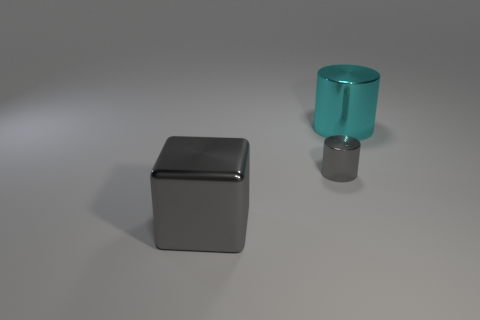Is the color of the cylinder behind the tiny metallic cylinder the same as the big thing that is to the left of the tiny shiny cylinder?
Offer a terse response. No. There is another thing that is the same size as the cyan metallic object; what is its color?
Give a very brief answer. Gray. Is the number of small metal cylinders that are left of the large cylinder the same as the number of tiny gray cylinders in front of the small cylinder?
Give a very brief answer. No. The gray object behind the thing that is in front of the small gray object is made of what material?
Your response must be concise. Metal. How many things are either large gray cubes or cyan matte spheres?
Your response must be concise. 1. There is a metallic object that is the same color as the big shiny block; what size is it?
Offer a very short reply. Small. Are there fewer shiny cubes than things?
Ensure brevity in your answer.  Yes. What size is the other cylinder that is made of the same material as the gray cylinder?
Give a very brief answer. Large. How big is the cyan object?
Provide a short and direct response. Large. What shape is the small thing?
Provide a succinct answer. Cylinder. 